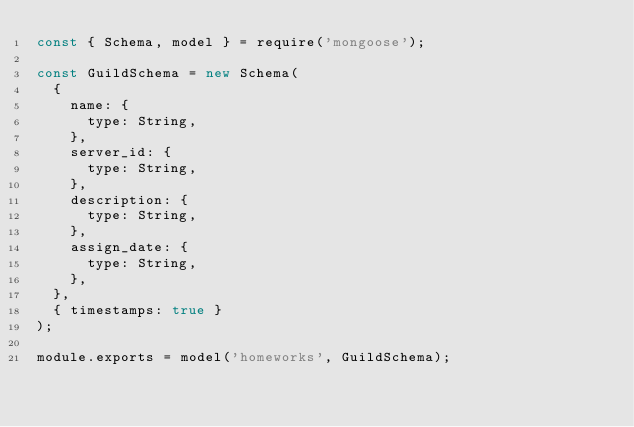Convert code to text. <code><loc_0><loc_0><loc_500><loc_500><_JavaScript_>const { Schema, model } = require('mongoose');

const GuildSchema = new Schema(
  {
    name: {
      type: String,
    },
    server_id: {
      type: String,
    },
    description: {
      type: String,
    },
    assign_date: {
      type: String,
    },
  },
  { timestamps: true }
);

module.exports = model('homeworks', GuildSchema);
</code> 